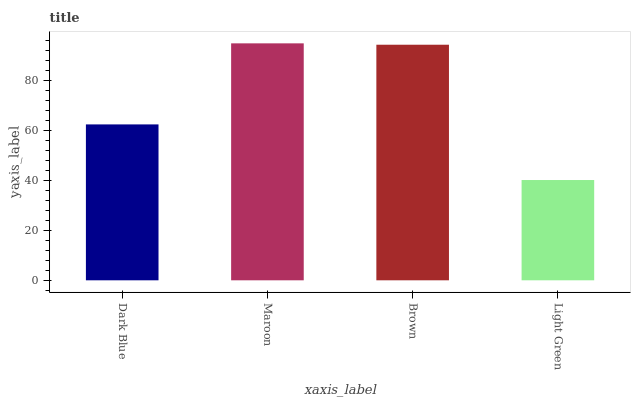Is Brown the minimum?
Answer yes or no. No. Is Brown the maximum?
Answer yes or no. No. Is Maroon greater than Brown?
Answer yes or no. Yes. Is Brown less than Maroon?
Answer yes or no. Yes. Is Brown greater than Maroon?
Answer yes or no. No. Is Maroon less than Brown?
Answer yes or no. No. Is Brown the high median?
Answer yes or no. Yes. Is Dark Blue the low median?
Answer yes or no. Yes. Is Maroon the high median?
Answer yes or no. No. Is Maroon the low median?
Answer yes or no. No. 